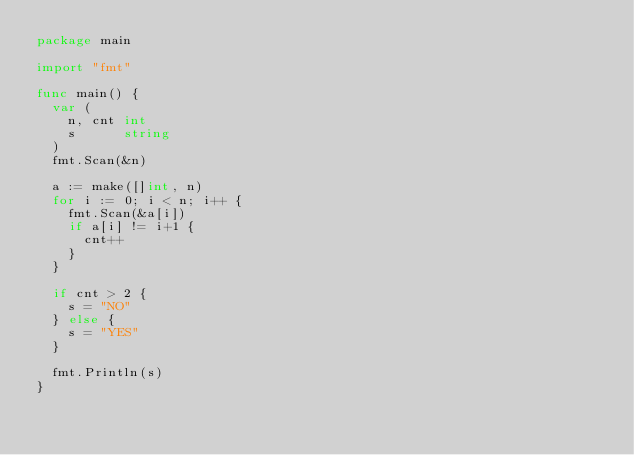<code> <loc_0><loc_0><loc_500><loc_500><_Go_>package main

import "fmt"

func main() {
	var (
		n, cnt int
		s      string
	)
	fmt.Scan(&n)

	a := make([]int, n)
	for i := 0; i < n; i++ {
		fmt.Scan(&a[i])
		if a[i] != i+1 {
			cnt++
		}
	}

	if cnt > 2 {
		s = "NO"
	} else {
		s = "YES"
	}

	fmt.Println(s)
}
</code> 